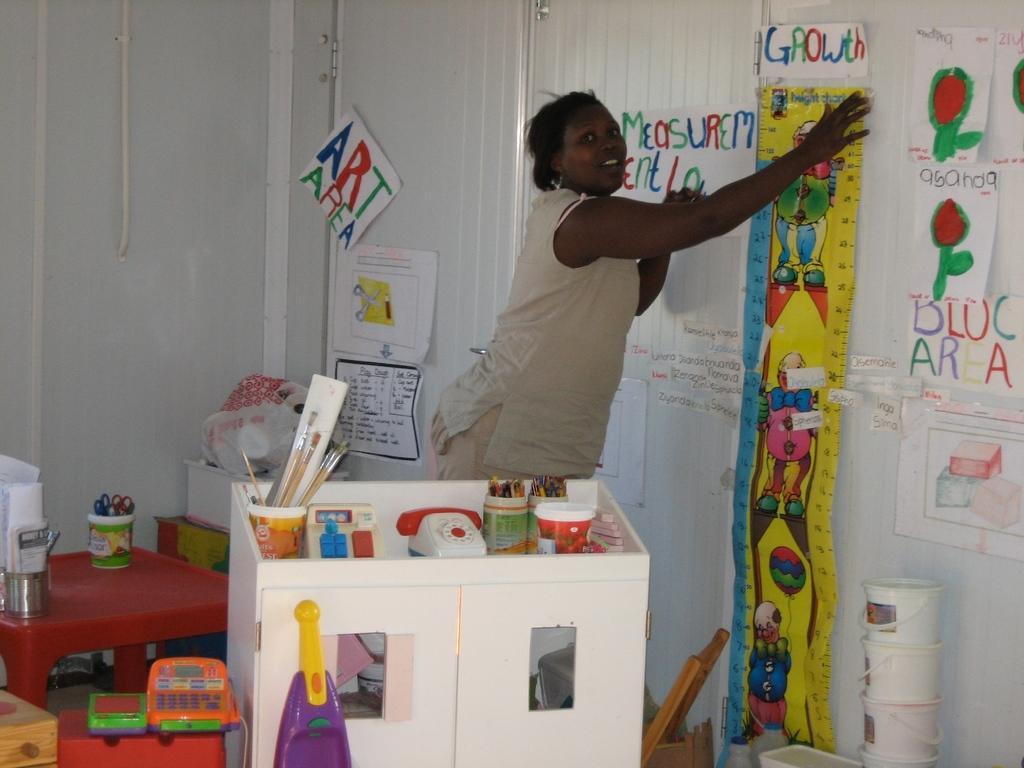Can you describe this image briefly? This image is taken indoors. In the background there is a wall and there are many charts with text and arts on the wall and there is a poster with a few images and text on it. In the middle of the image a woman is standing and she is holding a poster in her hands. There is a table with a few toys and a few things on it and there are many things on the floor. On the right side of the image there are a few buckets and a tub on the floor. 